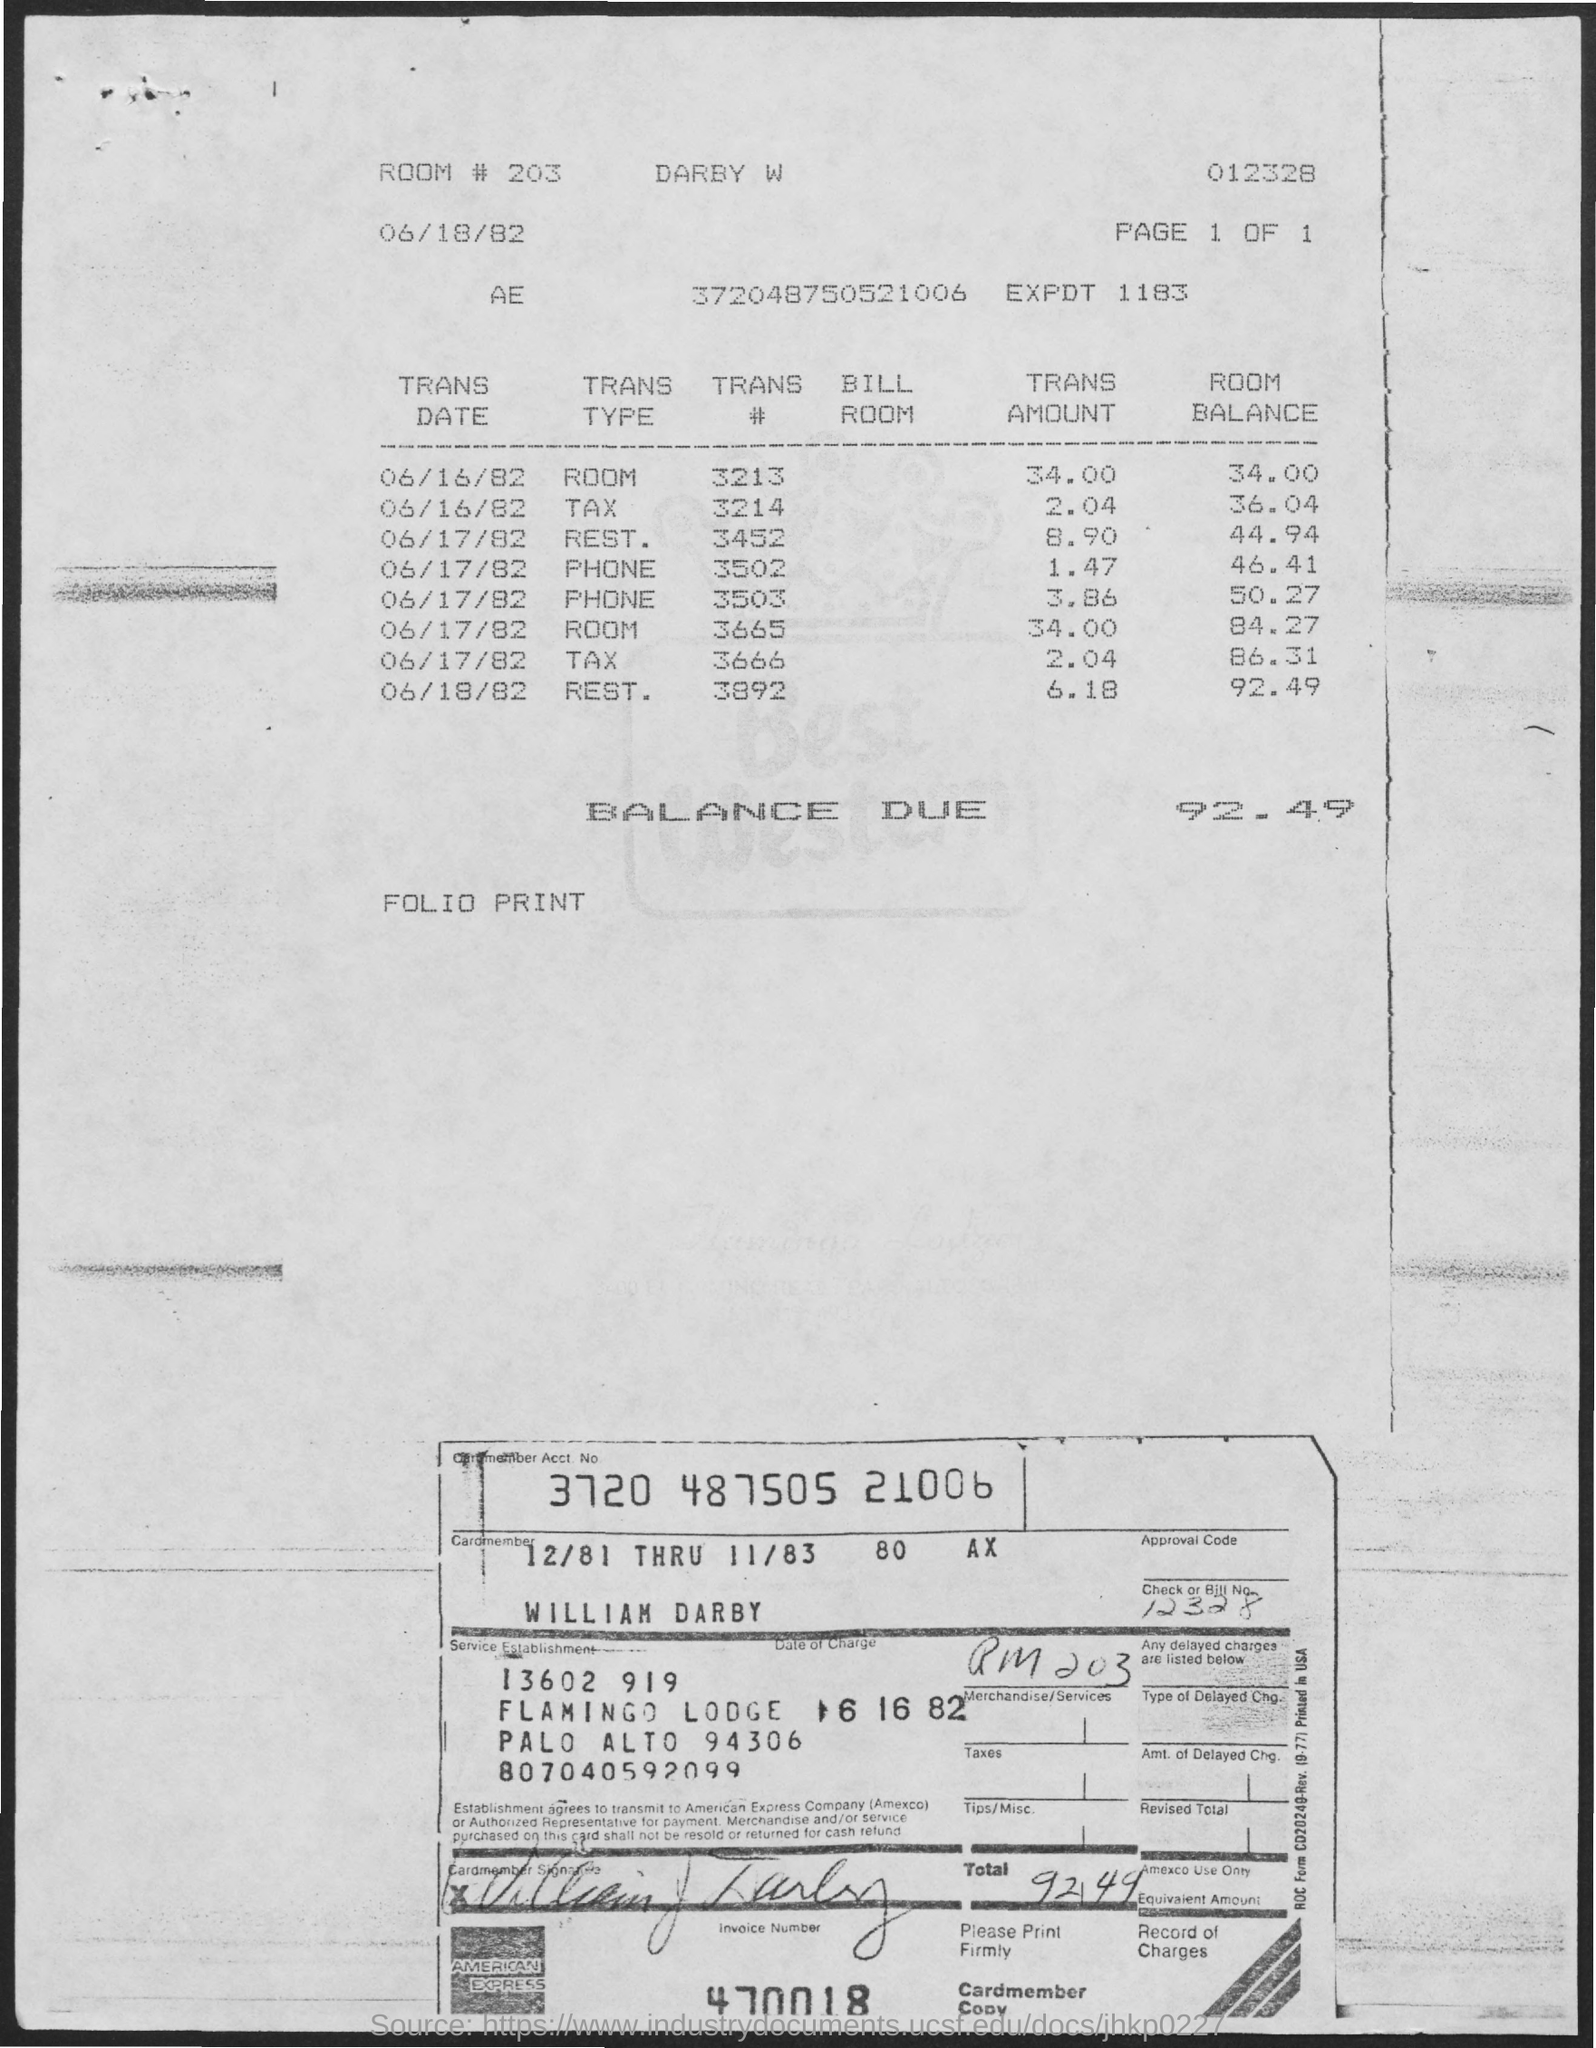Give some essential details in this illustration. The amount of balance due mentioned on the given page is 92.49. The transaction amount for the room on June 16, 1982, mentioned on the given page is $34.00. The transaction amount for tax on June 16th, 1982 was 2.04. The room number mentioned in the given page is 203. 